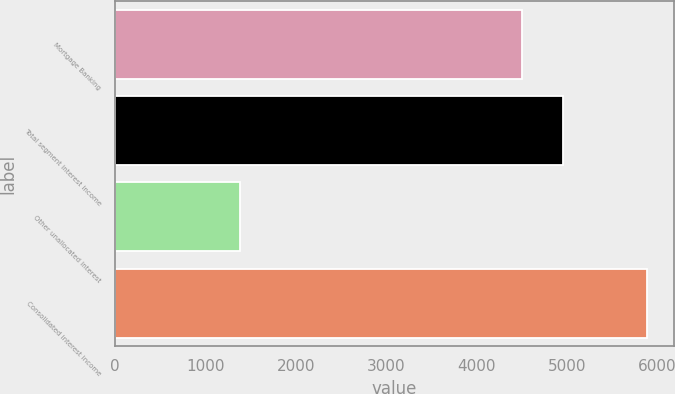<chart> <loc_0><loc_0><loc_500><loc_500><bar_chart><fcel>Mortgage Banking<fcel>Total segment interest income<fcel>Other unallocated interest<fcel>Consolidated interest income<nl><fcel>4504<fcel>4954.4<fcel>1388<fcel>5892<nl></chart> 